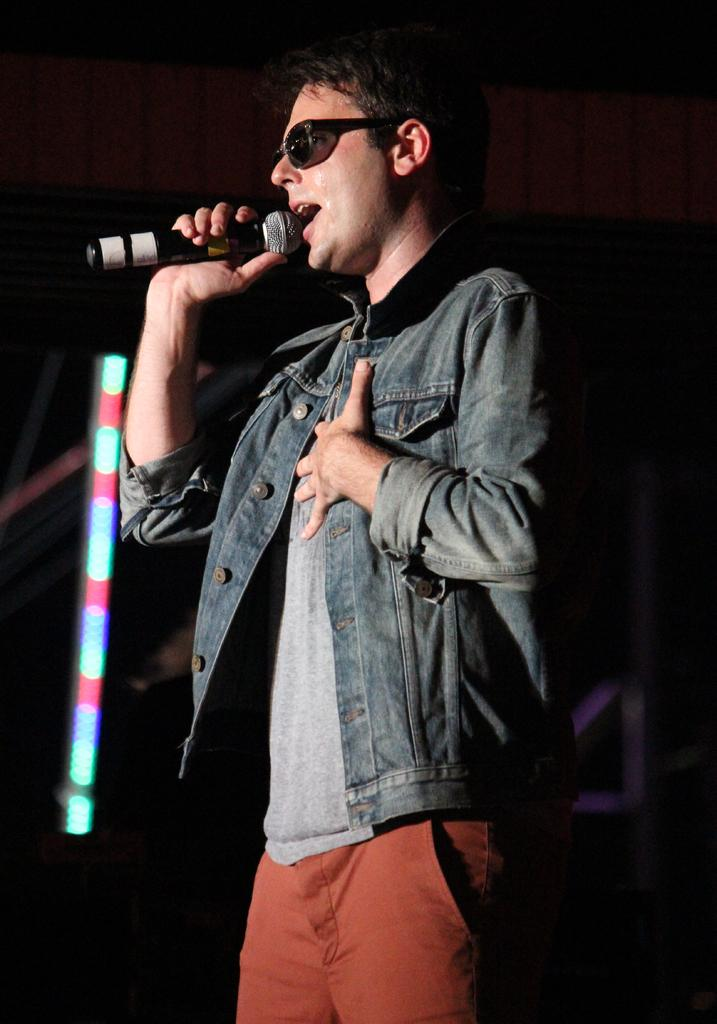What is the person in the image doing? The person is singing a song. What object is the person holding in the image? The person is holding a microphone. What color is the t-shirt the person is wearing? The person is wearing a grey t-shirt. What color are the pants the person is wearing? The person is wearing orange pants. What type of coat is the person wearing? The person is wearing a denim coat. What can be observed about the background of the image? The background of the image is dark. Is there a maid in the image? No, there is no maid present in the image. Can you see a cactus in the background of the image? No, there is no cactus visible in the image. 